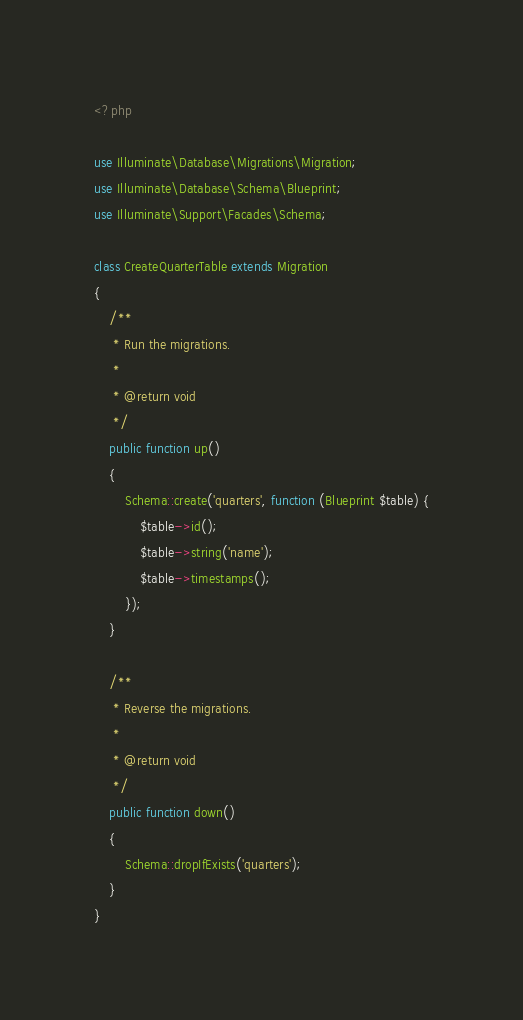Convert code to text. <code><loc_0><loc_0><loc_500><loc_500><_PHP_><?php

use Illuminate\Database\Migrations\Migration;
use Illuminate\Database\Schema\Blueprint;
use Illuminate\Support\Facades\Schema;

class CreateQuarterTable extends Migration
{
    /**
     * Run the migrations.
     *
     * @return void
     */
    public function up()
    {
        Schema::create('quarters', function (Blueprint $table) {
            $table->id();
            $table->string('name');
            $table->timestamps();
        });
    }

    /**
     * Reverse the migrations.
     *
     * @return void
     */
    public function down()
    {
        Schema::dropIfExists('quarters');
    }
}
</code> 